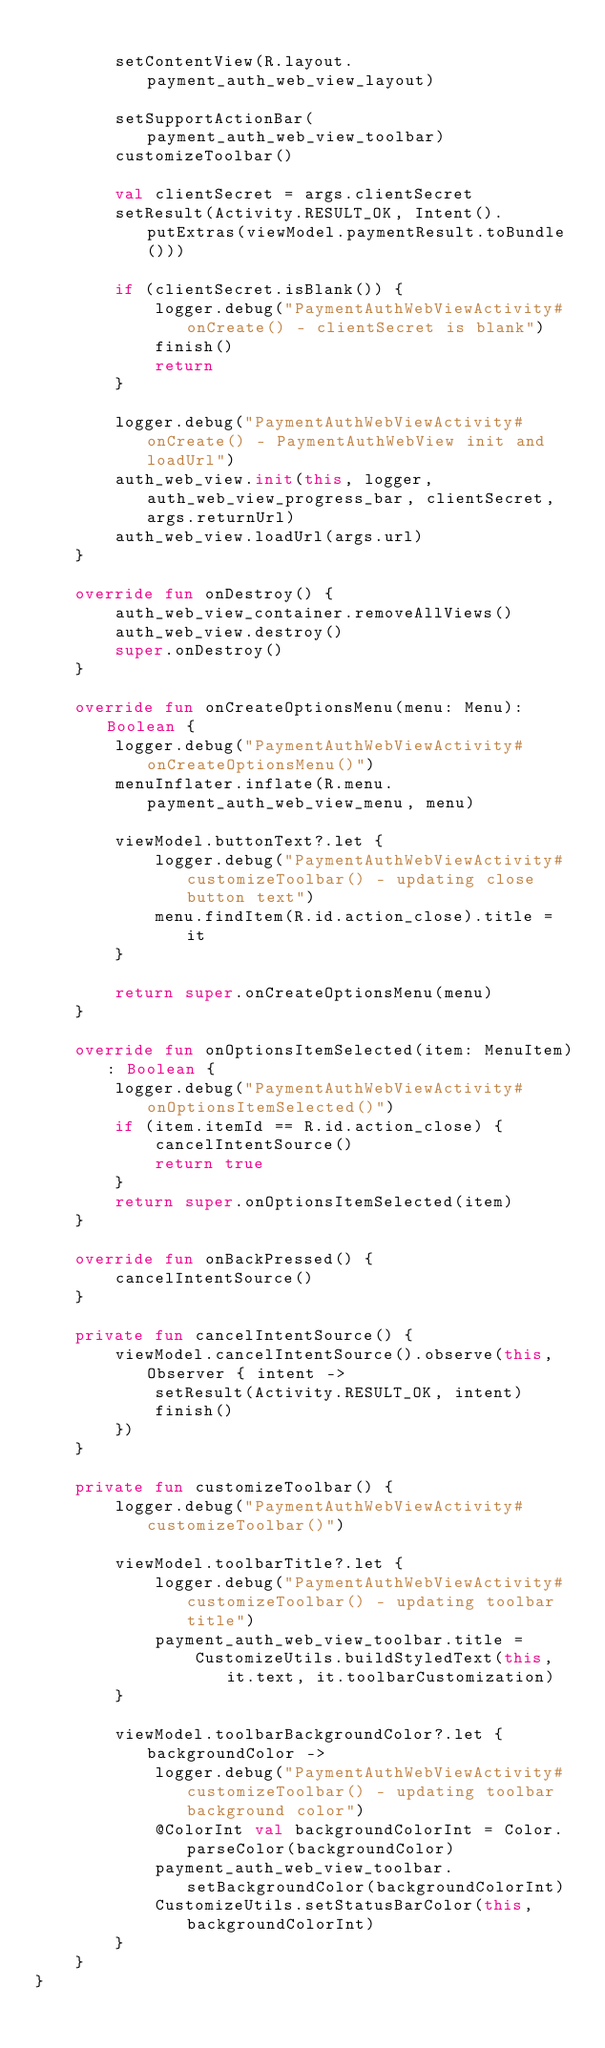<code> <loc_0><loc_0><loc_500><loc_500><_Kotlin_>
        setContentView(R.layout.payment_auth_web_view_layout)

        setSupportActionBar(payment_auth_web_view_toolbar)
        customizeToolbar()

        val clientSecret = args.clientSecret
        setResult(Activity.RESULT_OK, Intent().putExtras(viewModel.paymentResult.toBundle()))

        if (clientSecret.isBlank()) {
            logger.debug("PaymentAuthWebViewActivity#onCreate() - clientSecret is blank")
            finish()
            return
        }

        logger.debug("PaymentAuthWebViewActivity#onCreate() - PaymentAuthWebView init and loadUrl")
        auth_web_view.init(this, logger, auth_web_view_progress_bar, clientSecret, args.returnUrl)
        auth_web_view.loadUrl(args.url)
    }

    override fun onDestroy() {
        auth_web_view_container.removeAllViews()
        auth_web_view.destroy()
        super.onDestroy()
    }

    override fun onCreateOptionsMenu(menu: Menu): Boolean {
        logger.debug("PaymentAuthWebViewActivity#onCreateOptionsMenu()")
        menuInflater.inflate(R.menu.payment_auth_web_view_menu, menu)

        viewModel.buttonText?.let {
            logger.debug("PaymentAuthWebViewActivity#customizeToolbar() - updating close button text")
            menu.findItem(R.id.action_close).title = it
        }

        return super.onCreateOptionsMenu(menu)
    }

    override fun onOptionsItemSelected(item: MenuItem): Boolean {
        logger.debug("PaymentAuthWebViewActivity#onOptionsItemSelected()")
        if (item.itemId == R.id.action_close) {
            cancelIntentSource()
            return true
        }
        return super.onOptionsItemSelected(item)
    }

    override fun onBackPressed() {
        cancelIntentSource()
    }

    private fun cancelIntentSource() {
        viewModel.cancelIntentSource().observe(this, Observer { intent ->
            setResult(Activity.RESULT_OK, intent)
            finish()
        })
    }

    private fun customizeToolbar() {
        logger.debug("PaymentAuthWebViewActivity#customizeToolbar()")

        viewModel.toolbarTitle?.let {
            logger.debug("PaymentAuthWebViewActivity#customizeToolbar() - updating toolbar title")
            payment_auth_web_view_toolbar.title =
                CustomizeUtils.buildStyledText(this, it.text, it.toolbarCustomization)
        }

        viewModel.toolbarBackgroundColor?.let { backgroundColor ->
            logger.debug("PaymentAuthWebViewActivity#customizeToolbar() - updating toolbar background color")
            @ColorInt val backgroundColorInt = Color.parseColor(backgroundColor)
            payment_auth_web_view_toolbar.setBackgroundColor(backgroundColorInt)
            CustomizeUtils.setStatusBarColor(this, backgroundColorInt)
        }
    }
}
</code> 